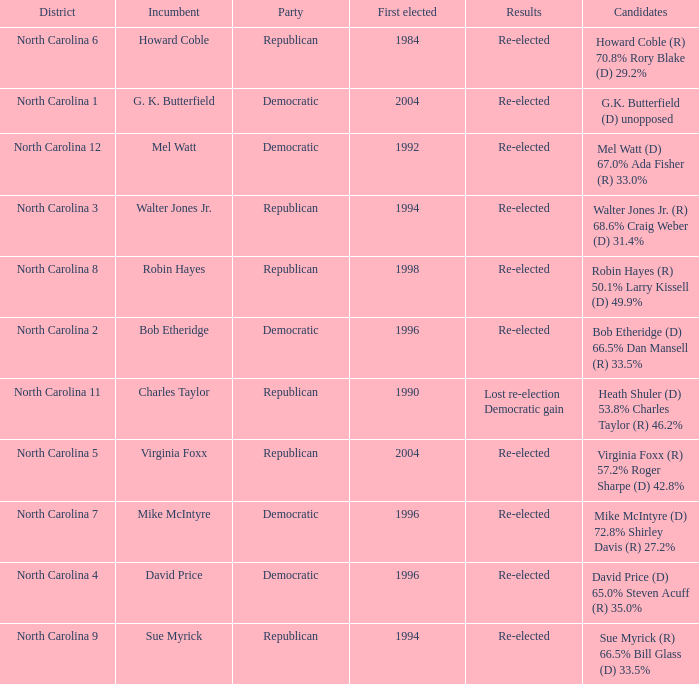How many times did Robin Hayes run? 1.0. 